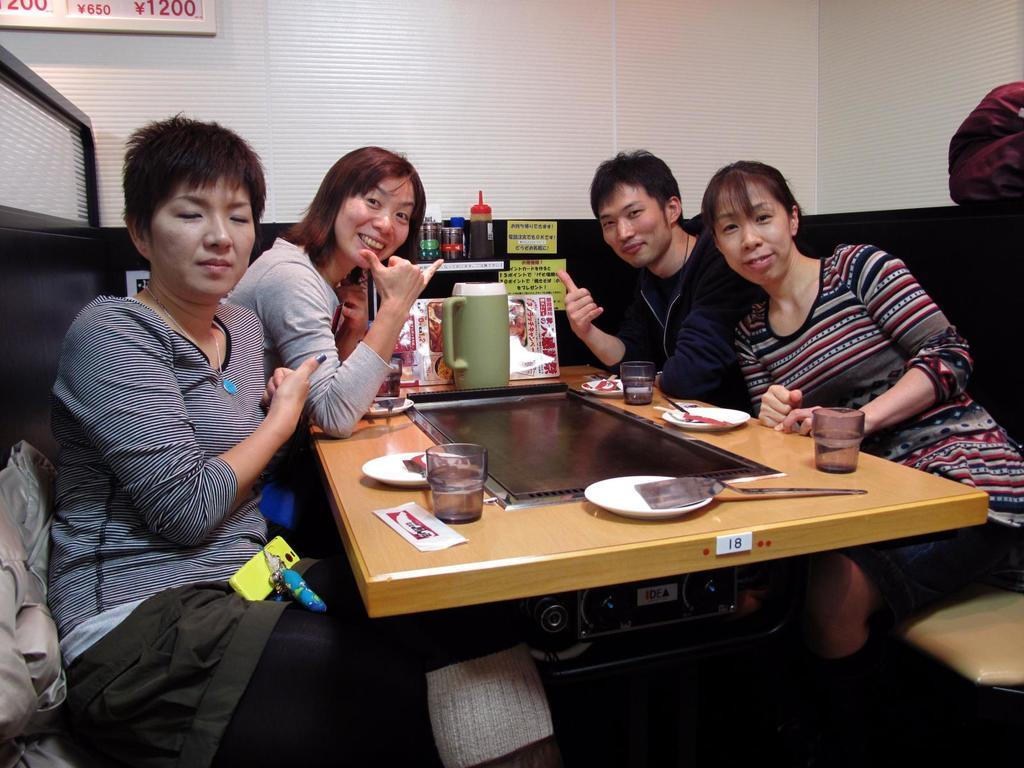How many people are in the image? There are four people in the image. Where are the four people located? The four people are at a restaurant. What are the four people doing in the image? The four people are posing for a camera. What is the gender distribution of the people in the image? Three of the people are women, and one is a man. What type of lettuce is being served at the restaurant in the image? There is no lettuce visible in the image, and the image does not provide information about the food being served at the restaurant. 